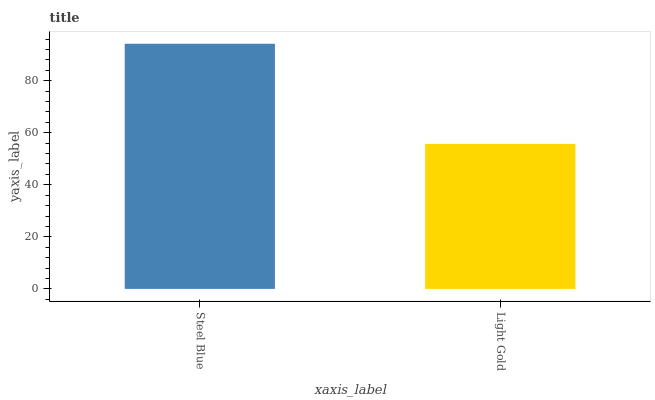Is Light Gold the maximum?
Answer yes or no. No. Is Steel Blue greater than Light Gold?
Answer yes or no. Yes. Is Light Gold less than Steel Blue?
Answer yes or no. Yes. Is Light Gold greater than Steel Blue?
Answer yes or no. No. Is Steel Blue less than Light Gold?
Answer yes or no. No. Is Steel Blue the high median?
Answer yes or no. Yes. Is Light Gold the low median?
Answer yes or no. Yes. Is Light Gold the high median?
Answer yes or no. No. Is Steel Blue the low median?
Answer yes or no. No. 